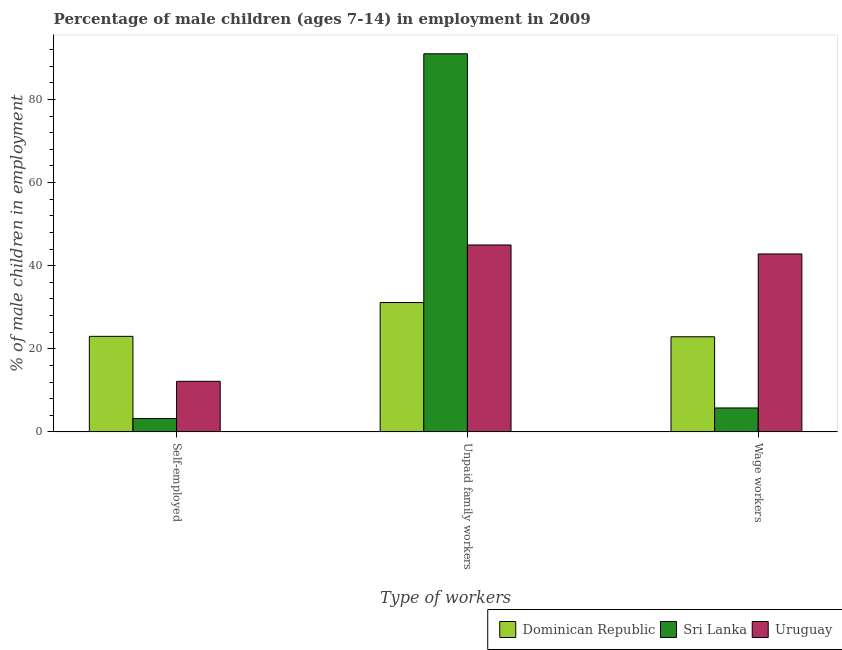How many different coloured bars are there?
Give a very brief answer. 3. How many groups of bars are there?
Your answer should be very brief. 3. Are the number of bars per tick equal to the number of legend labels?
Offer a very short reply. Yes. Are the number of bars on each tick of the X-axis equal?
Keep it short and to the point. Yes. What is the label of the 3rd group of bars from the left?
Your answer should be very brief. Wage workers. What is the percentage of children employed as unpaid family workers in Dominican Republic?
Your response must be concise. 31.14. Across all countries, what is the maximum percentage of children employed as wage workers?
Your answer should be very brief. 42.83. Across all countries, what is the minimum percentage of self employed children?
Offer a terse response. 3.23. In which country was the percentage of children employed as wage workers maximum?
Offer a very short reply. Uruguay. In which country was the percentage of children employed as wage workers minimum?
Keep it short and to the point. Sri Lanka. What is the total percentage of children employed as unpaid family workers in the graph?
Ensure brevity in your answer.  167.13. What is the difference between the percentage of children employed as wage workers in Dominican Republic and that in Sri Lanka?
Your answer should be compact. 17.13. What is the difference between the percentage of self employed children in Sri Lanka and the percentage of children employed as wage workers in Uruguay?
Give a very brief answer. -39.6. What is the average percentage of children employed as wage workers per country?
Make the answer very short. 23.83. What is the difference between the percentage of children employed as unpaid family workers and percentage of self employed children in Uruguay?
Keep it short and to the point. 32.81. In how many countries, is the percentage of children employed as wage workers greater than 88 %?
Your answer should be very brief. 0. What is the ratio of the percentage of children employed as unpaid family workers in Dominican Republic to that in Sri Lanka?
Your answer should be very brief. 0.34. What is the difference between the highest and the second highest percentage of children employed as wage workers?
Give a very brief answer. 19.93. What is the difference between the highest and the lowest percentage of self employed children?
Offer a very short reply. 19.77. What does the 2nd bar from the left in Unpaid family workers represents?
Your response must be concise. Sri Lanka. What does the 1st bar from the right in Self-employed represents?
Give a very brief answer. Uruguay. Are all the bars in the graph horizontal?
Offer a terse response. No. How many countries are there in the graph?
Your response must be concise. 3. Are the values on the major ticks of Y-axis written in scientific E-notation?
Your answer should be very brief. No. What is the title of the graph?
Give a very brief answer. Percentage of male children (ages 7-14) in employment in 2009. Does "Spain" appear as one of the legend labels in the graph?
Your response must be concise. No. What is the label or title of the X-axis?
Your response must be concise. Type of workers. What is the label or title of the Y-axis?
Offer a very short reply. % of male children in employment. What is the % of male children in employment of Dominican Republic in Self-employed?
Provide a short and direct response. 23. What is the % of male children in employment in Sri Lanka in Self-employed?
Offer a terse response. 3.23. What is the % of male children in employment in Uruguay in Self-employed?
Offer a very short reply. 12.18. What is the % of male children in employment in Dominican Republic in Unpaid family workers?
Provide a short and direct response. 31.14. What is the % of male children in employment of Sri Lanka in Unpaid family workers?
Ensure brevity in your answer.  91. What is the % of male children in employment of Uruguay in Unpaid family workers?
Offer a terse response. 44.99. What is the % of male children in employment in Dominican Republic in Wage workers?
Keep it short and to the point. 22.9. What is the % of male children in employment in Sri Lanka in Wage workers?
Your answer should be very brief. 5.77. What is the % of male children in employment in Uruguay in Wage workers?
Keep it short and to the point. 42.83. Across all Type of workers, what is the maximum % of male children in employment in Dominican Republic?
Give a very brief answer. 31.14. Across all Type of workers, what is the maximum % of male children in employment of Sri Lanka?
Provide a short and direct response. 91. Across all Type of workers, what is the maximum % of male children in employment in Uruguay?
Ensure brevity in your answer.  44.99. Across all Type of workers, what is the minimum % of male children in employment of Dominican Republic?
Offer a terse response. 22.9. Across all Type of workers, what is the minimum % of male children in employment of Sri Lanka?
Make the answer very short. 3.23. Across all Type of workers, what is the minimum % of male children in employment in Uruguay?
Ensure brevity in your answer.  12.18. What is the total % of male children in employment of Dominican Republic in the graph?
Keep it short and to the point. 77.04. What is the difference between the % of male children in employment of Dominican Republic in Self-employed and that in Unpaid family workers?
Offer a very short reply. -8.14. What is the difference between the % of male children in employment in Sri Lanka in Self-employed and that in Unpaid family workers?
Your answer should be very brief. -87.77. What is the difference between the % of male children in employment of Uruguay in Self-employed and that in Unpaid family workers?
Give a very brief answer. -32.81. What is the difference between the % of male children in employment in Sri Lanka in Self-employed and that in Wage workers?
Give a very brief answer. -2.54. What is the difference between the % of male children in employment in Uruguay in Self-employed and that in Wage workers?
Keep it short and to the point. -30.65. What is the difference between the % of male children in employment in Dominican Republic in Unpaid family workers and that in Wage workers?
Your response must be concise. 8.24. What is the difference between the % of male children in employment of Sri Lanka in Unpaid family workers and that in Wage workers?
Keep it short and to the point. 85.23. What is the difference between the % of male children in employment of Uruguay in Unpaid family workers and that in Wage workers?
Keep it short and to the point. 2.16. What is the difference between the % of male children in employment in Dominican Republic in Self-employed and the % of male children in employment in Sri Lanka in Unpaid family workers?
Provide a succinct answer. -68. What is the difference between the % of male children in employment in Dominican Republic in Self-employed and the % of male children in employment in Uruguay in Unpaid family workers?
Provide a succinct answer. -21.99. What is the difference between the % of male children in employment of Sri Lanka in Self-employed and the % of male children in employment of Uruguay in Unpaid family workers?
Provide a succinct answer. -41.76. What is the difference between the % of male children in employment in Dominican Republic in Self-employed and the % of male children in employment in Sri Lanka in Wage workers?
Offer a terse response. 17.23. What is the difference between the % of male children in employment in Dominican Republic in Self-employed and the % of male children in employment in Uruguay in Wage workers?
Keep it short and to the point. -19.83. What is the difference between the % of male children in employment in Sri Lanka in Self-employed and the % of male children in employment in Uruguay in Wage workers?
Ensure brevity in your answer.  -39.6. What is the difference between the % of male children in employment of Dominican Republic in Unpaid family workers and the % of male children in employment of Sri Lanka in Wage workers?
Your answer should be compact. 25.37. What is the difference between the % of male children in employment in Dominican Republic in Unpaid family workers and the % of male children in employment in Uruguay in Wage workers?
Give a very brief answer. -11.69. What is the difference between the % of male children in employment in Sri Lanka in Unpaid family workers and the % of male children in employment in Uruguay in Wage workers?
Provide a short and direct response. 48.17. What is the average % of male children in employment of Dominican Republic per Type of workers?
Offer a terse response. 25.68. What is the average % of male children in employment in Sri Lanka per Type of workers?
Ensure brevity in your answer.  33.33. What is the average % of male children in employment in Uruguay per Type of workers?
Your answer should be compact. 33.33. What is the difference between the % of male children in employment in Dominican Republic and % of male children in employment in Sri Lanka in Self-employed?
Your answer should be compact. 19.77. What is the difference between the % of male children in employment in Dominican Republic and % of male children in employment in Uruguay in Self-employed?
Your response must be concise. 10.82. What is the difference between the % of male children in employment of Sri Lanka and % of male children in employment of Uruguay in Self-employed?
Your answer should be very brief. -8.95. What is the difference between the % of male children in employment of Dominican Republic and % of male children in employment of Sri Lanka in Unpaid family workers?
Your answer should be compact. -59.86. What is the difference between the % of male children in employment of Dominican Republic and % of male children in employment of Uruguay in Unpaid family workers?
Offer a very short reply. -13.85. What is the difference between the % of male children in employment of Sri Lanka and % of male children in employment of Uruguay in Unpaid family workers?
Provide a succinct answer. 46.01. What is the difference between the % of male children in employment of Dominican Republic and % of male children in employment of Sri Lanka in Wage workers?
Ensure brevity in your answer.  17.13. What is the difference between the % of male children in employment of Dominican Republic and % of male children in employment of Uruguay in Wage workers?
Offer a very short reply. -19.93. What is the difference between the % of male children in employment of Sri Lanka and % of male children in employment of Uruguay in Wage workers?
Provide a succinct answer. -37.06. What is the ratio of the % of male children in employment of Dominican Republic in Self-employed to that in Unpaid family workers?
Provide a succinct answer. 0.74. What is the ratio of the % of male children in employment in Sri Lanka in Self-employed to that in Unpaid family workers?
Your response must be concise. 0.04. What is the ratio of the % of male children in employment of Uruguay in Self-employed to that in Unpaid family workers?
Your response must be concise. 0.27. What is the ratio of the % of male children in employment in Sri Lanka in Self-employed to that in Wage workers?
Provide a succinct answer. 0.56. What is the ratio of the % of male children in employment in Uruguay in Self-employed to that in Wage workers?
Offer a terse response. 0.28. What is the ratio of the % of male children in employment of Dominican Republic in Unpaid family workers to that in Wage workers?
Offer a terse response. 1.36. What is the ratio of the % of male children in employment of Sri Lanka in Unpaid family workers to that in Wage workers?
Your answer should be very brief. 15.77. What is the ratio of the % of male children in employment in Uruguay in Unpaid family workers to that in Wage workers?
Your answer should be very brief. 1.05. What is the difference between the highest and the second highest % of male children in employment of Dominican Republic?
Keep it short and to the point. 8.14. What is the difference between the highest and the second highest % of male children in employment in Sri Lanka?
Provide a short and direct response. 85.23. What is the difference between the highest and the second highest % of male children in employment of Uruguay?
Your answer should be very brief. 2.16. What is the difference between the highest and the lowest % of male children in employment of Dominican Republic?
Ensure brevity in your answer.  8.24. What is the difference between the highest and the lowest % of male children in employment in Sri Lanka?
Offer a very short reply. 87.77. What is the difference between the highest and the lowest % of male children in employment of Uruguay?
Your answer should be very brief. 32.81. 